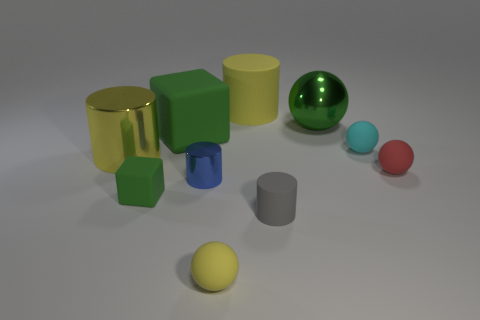Are there any tiny brown blocks that have the same material as the blue cylinder?
Provide a short and direct response. No. There is a big matte object behind the green metallic sphere; are there any rubber cylinders in front of it?
Offer a terse response. Yes. Do the metallic thing that is right of the gray cylinder and the small blue metallic thing have the same size?
Your answer should be compact. No. What is the size of the gray thing?
Ensure brevity in your answer.  Small. Is there a tiny block that has the same color as the large metal cylinder?
Ensure brevity in your answer.  No. What number of small things are purple cylinders or shiny cylinders?
Give a very brief answer. 1. What is the size of the matte object that is both behind the small red rubber sphere and right of the gray object?
Provide a succinct answer. Small. What number of yellow cylinders are in front of the large block?
Your response must be concise. 1. There is a yellow object that is in front of the large green metal sphere and behind the yellow matte ball; what is its shape?
Provide a succinct answer. Cylinder. There is a ball that is the same color as the large metallic cylinder; what is its material?
Ensure brevity in your answer.  Rubber. 